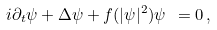Convert formula to latex. <formula><loc_0><loc_0><loc_500><loc_500>i \partial _ { t } \psi + \Delta \psi + f ( | \psi | ^ { 2 } ) \psi \ = 0 \, ,</formula> 